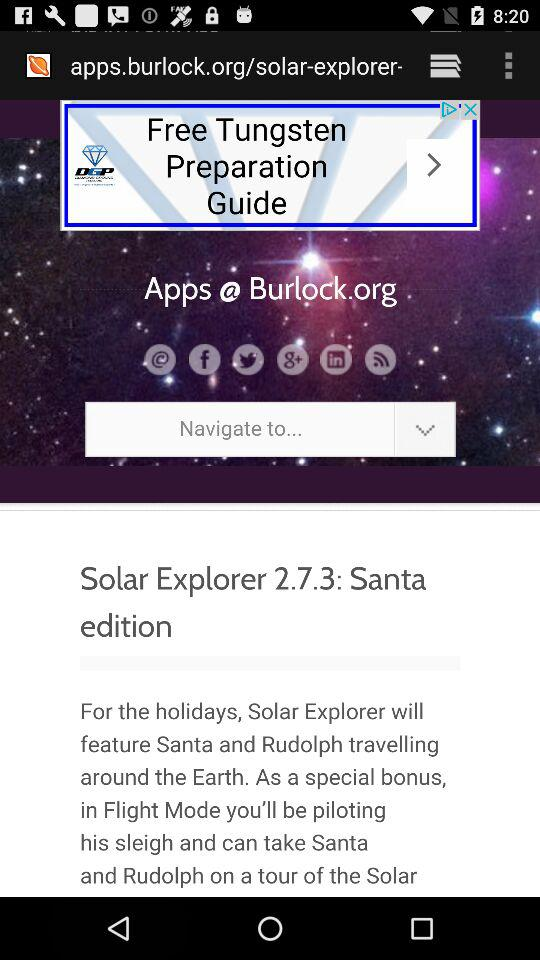What are e options to share?
When the provided information is insufficient, respond with <no answer>. <no answer> 